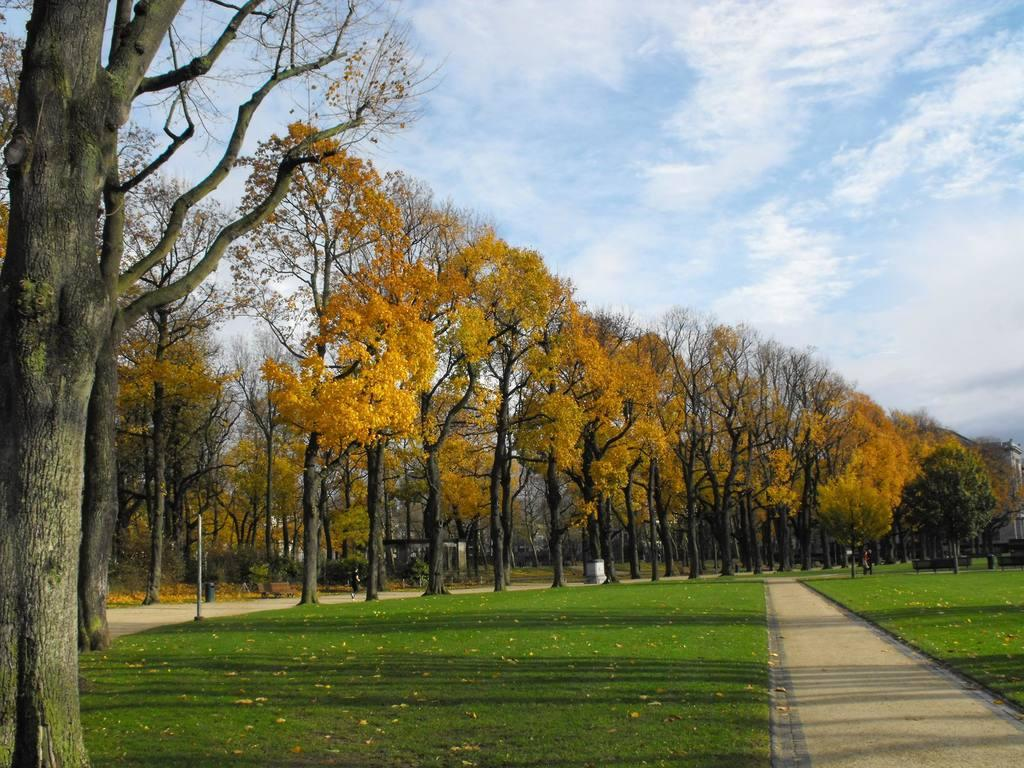What type of vegetation is present in the image? There is a group of trees in the image, and grass is also visible. Can you describe the texture of the trees in the image? The bark of a tree is visible in the image. What structure can be seen in the image? There is a pole in the image. What type of surface is present in the image? There is a pathway in the image. What part of the natural environment is visible in the image? The sky is visible in the image, and it appears cloudy. Can you describe the cork on the tree in the image? There is no cork present on the trees in the image. What type of animal can be seen climbing the tree in the image? There are no animals visible in the image, including squirrels. 